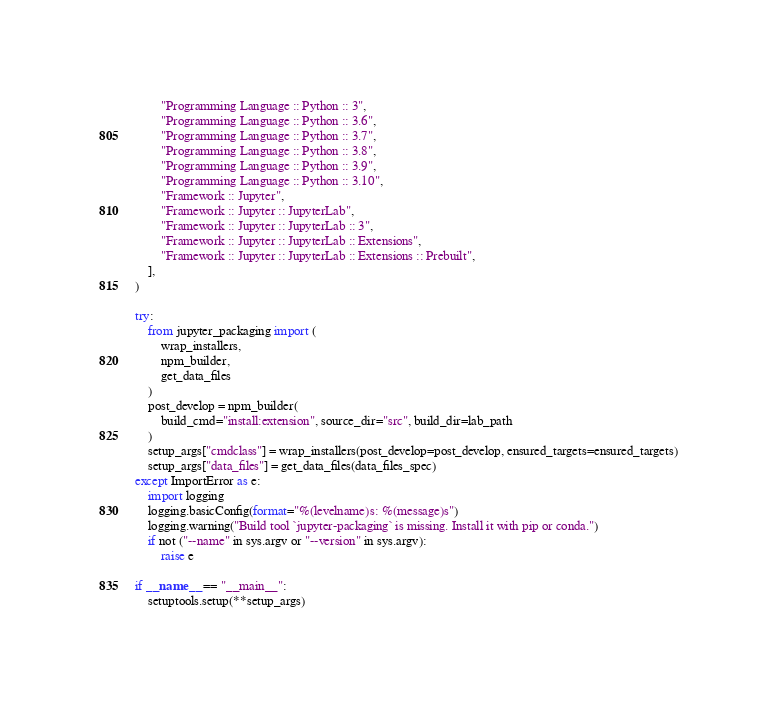Convert code to text. <code><loc_0><loc_0><loc_500><loc_500><_Python_>        "Programming Language :: Python :: 3",
        "Programming Language :: Python :: 3.6",
        "Programming Language :: Python :: 3.7",
        "Programming Language :: Python :: 3.8",
        "Programming Language :: Python :: 3.9",
        "Programming Language :: Python :: 3.10",
        "Framework :: Jupyter",
        "Framework :: Jupyter :: JupyterLab",
        "Framework :: Jupyter :: JupyterLab :: 3",
        "Framework :: Jupyter :: JupyterLab :: Extensions",
        "Framework :: Jupyter :: JupyterLab :: Extensions :: Prebuilt",
    ],
)

try:
    from jupyter_packaging import (
        wrap_installers,
        npm_builder,
        get_data_files
    )
    post_develop = npm_builder(
        build_cmd="install:extension", source_dir="src", build_dir=lab_path
    )
    setup_args["cmdclass"] = wrap_installers(post_develop=post_develop, ensured_targets=ensured_targets)
    setup_args["data_files"] = get_data_files(data_files_spec)
except ImportError as e:
    import logging
    logging.basicConfig(format="%(levelname)s: %(message)s")
    logging.warning("Build tool `jupyter-packaging` is missing. Install it with pip or conda.")
    if not ("--name" in sys.argv or "--version" in sys.argv):
        raise e

if __name__ == "__main__":
    setuptools.setup(**setup_args)
</code> 